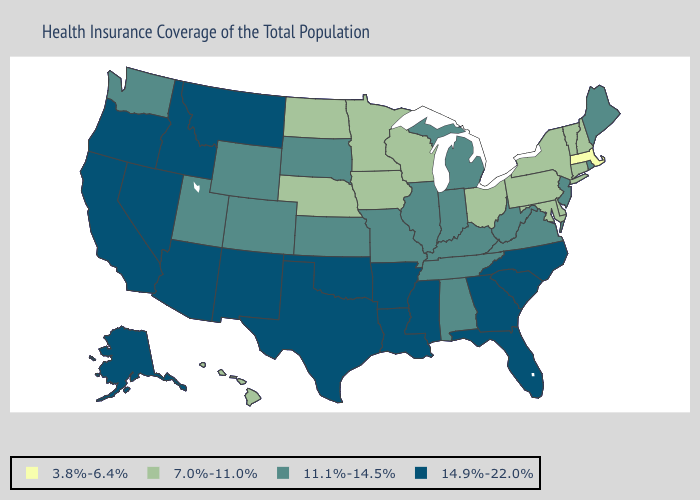What is the value of Arizona?
Write a very short answer. 14.9%-22.0%. What is the lowest value in states that border New Mexico?
Write a very short answer. 11.1%-14.5%. Does Delaware have the lowest value in the USA?
Be succinct. No. Name the states that have a value in the range 11.1%-14.5%?
Short answer required. Alabama, Colorado, Illinois, Indiana, Kansas, Kentucky, Maine, Michigan, Missouri, New Jersey, Rhode Island, South Dakota, Tennessee, Utah, Virginia, Washington, West Virginia, Wyoming. Which states have the lowest value in the West?
Answer briefly. Hawaii. What is the value of Colorado?
Quick response, please. 11.1%-14.5%. Name the states that have a value in the range 14.9%-22.0%?
Answer briefly. Alaska, Arizona, Arkansas, California, Florida, Georgia, Idaho, Louisiana, Mississippi, Montana, Nevada, New Mexico, North Carolina, Oklahoma, Oregon, South Carolina, Texas. Name the states that have a value in the range 3.8%-6.4%?
Write a very short answer. Massachusetts. Name the states that have a value in the range 11.1%-14.5%?
Short answer required. Alabama, Colorado, Illinois, Indiana, Kansas, Kentucky, Maine, Michigan, Missouri, New Jersey, Rhode Island, South Dakota, Tennessee, Utah, Virginia, Washington, West Virginia, Wyoming. Name the states that have a value in the range 11.1%-14.5%?
Be succinct. Alabama, Colorado, Illinois, Indiana, Kansas, Kentucky, Maine, Michigan, Missouri, New Jersey, Rhode Island, South Dakota, Tennessee, Utah, Virginia, Washington, West Virginia, Wyoming. Does Massachusetts have the lowest value in the Northeast?
Answer briefly. Yes. Name the states that have a value in the range 3.8%-6.4%?
Short answer required. Massachusetts. Name the states that have a value in the range 7.0%-11.0%?
Write a very short answer. Connecticut, Delaware, Hawaii, Iowa, Maryland, Minnesota, Nebraska, New Hampshire, New York, North Dakota, Ohio, Pennsylvania, Vermont, Wisconsin. Among the states that border Idaho , which have the highest value?
Give a very brief answer. Montana, Nevada, Oregon. What is the highest value in the USA?
Keep it brief. 14.9%-22.0%. 